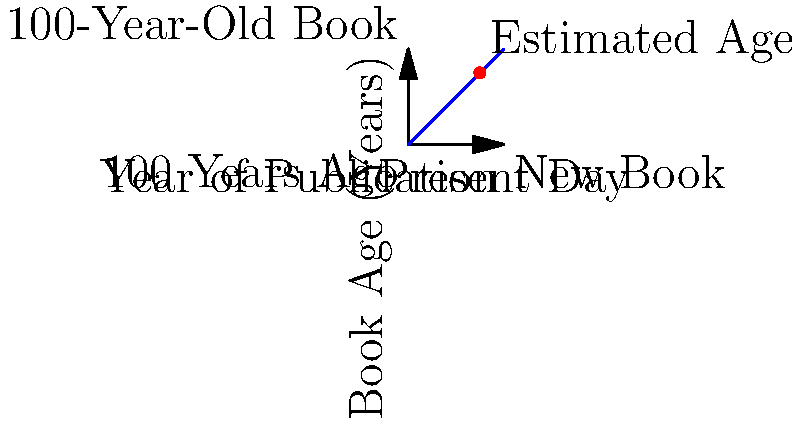Based on the image showing the relationship between a book's year of publication and its age, if you were to find an antique book that you estimate to be about 75 years old, approximately what year would it have been published? Let's approach this step-by-step:

1. The graph shows a linear relationship between the year of publication and the age of a book.
2. The x-axis represents the year of publication, with the present day at the far right (100 on the scale).
3. The y-axis represents the age of the book, with 100 years being the maximum shown.
4. The red dot on the graph indicates an estimated age of 75 years.
5. To find the year of publication, we need to subtract the estimated age from the current year.
6. Let's assume the current year is 2023 for this calculation.
7. Mathematical representation: Year of Publication = Current Year - Estimated Age
8. Plugging in the values: Year of Publication = 2023 - 75
9. Calculating: Year of Publication = 1948

Therefore, a book estimated to be 75 years old would have been published around 1948.
Answer: 1948 